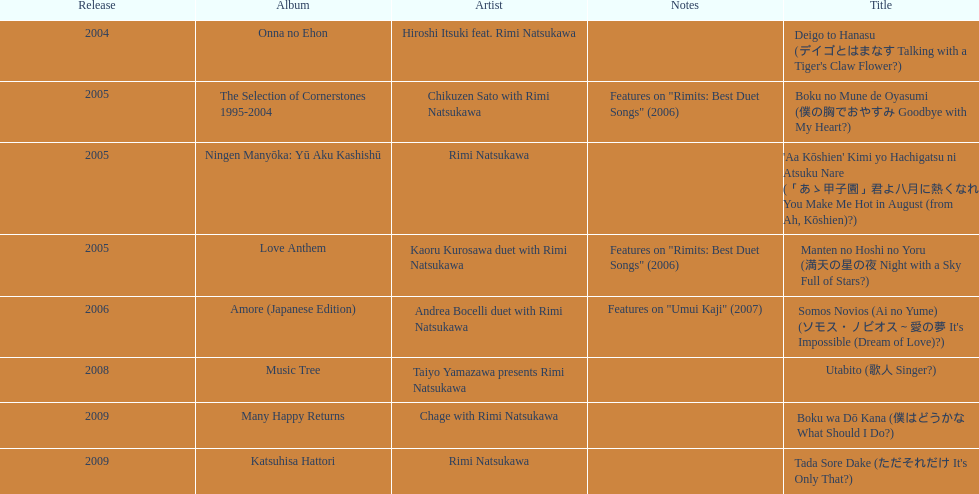What year was the first title released? 2004. 